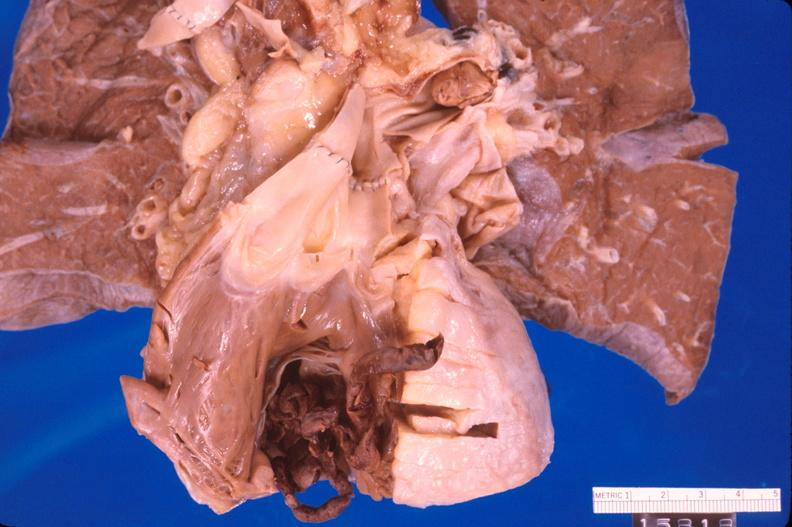where is this?
Answer the question using a single word or phrase. Heart 